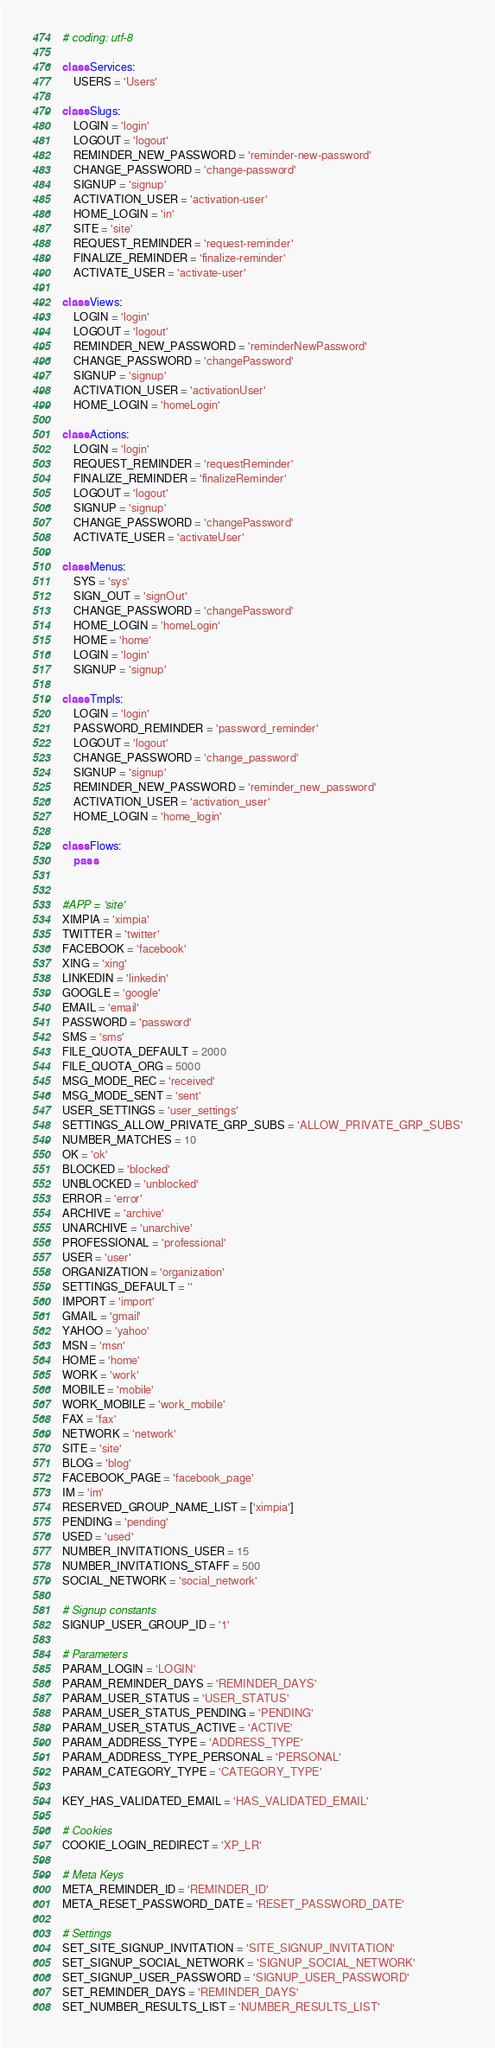Convert code to text. <code><loc_0><loc_0><loc_500><loc_500><_Python_># coding: utf-8

class Services:
    USERS = 'Users'

class Slugs:
    LOGIN = 'login'
    LOGOUT = 'logout'
    REMINDER_NEW_PASSWORD = 'reminder-new-password'
    CHANGE_PASSWORD = 'change-password'
    SIGNUP = 'signup'
    ACTIVATION_USER = 'activation-user'
    HOME_LOGIN = 'in'
    SITE = 'site'
    REQUEST_REMINDER = 'request-reminder'
    FINALIZE_REMINDER = 'finalize-reminder'
    ACTIVATE_USER = 'activate-user'

class Views:
    LOGIN = 'login'
    LOGOUT = 'logout'
    REMINDER_NEW_PASSWORD = 'reminderNewPassword'
    CHANGE_PASSWORD = 'changePassword'
    SIGNUP = 'signup'
    ACTIVATION_USER = 'activationUser'
    HOME_LOGIN = 'homeLogin'

class Actions:
    LOGIN = 'login'
    REQUEST_REMINDER = 'requestReminder'
    FINALIZE_REMINDER = 'finalizeReminder'
    LOGOUT = 'logout'
    SIGNUP = 'signup'
    CHANGE_PASSWORD = 'changePassword'
    ACTIVATE_USER = 'activateUser'    

class Menus:
    SYS = 'sys'
    SIGN_OUT = 'signOut'
    CHANGE_PASSWORD = 'changePassword'
    HOME_LOGIN = 'homeLogin'
    HOME = 'home'
    LOGIN = 'login'
    SIGNUP = 'signup'

class Tmpls:
    LOGIN = 'login'
    PASSWORD_REMINDER = 'password_reminder'
    LOGOUT = 'logout'
    CHANGE_PASSWORD = 'change_password'
    SIGNUP = 'signup'
    REMINDER_NEW_PASSWORD = 'reminder_new_password'
    ACTIVATION_USER = 'activation_user'
    HOME_LOGIN = 'home_login'

class Flows:
    pass


#APP = 'site'
XIMPIA = 'ximpia'
TWITTER = 'twitter'
FACEBOOK = 'facebook'
XING = 'xing'
LINKEDIN = 'linkedin'
GOOGLE = 'google'
EMAIL = 'email'
PASSWORD = 'password'
SMS = 'sms'
FILE_QUOTA_DEFAULT = 2000
FILE_QUOTA_ORG = 5000
MSG_MODE_REC = 'received'
MSG_MODE_SENT = 'sent'
USER_SETTINGS = 'user_settings'
SETTINGS_ALLOW_PRIVATE_GRP_SUBS = 'ALLOW_PRIVATE_GRP_SUBS'
NUMBER_MATCHES = 10
OK = 'ok'
BLOCKED = 'blocked'
UNBLOCKED = 'unblocked'
ERROR = 'error'
ARCHIVE = 'archive'
UNARCHIVE = 'unarchive'
PROFESSIONAL = 'professional'
USER = 'user'
ORGANIZATION = 'organization'
SETTINGS_DEFAULT = ''
IMPORT = 'import'
GMAIL = 'gmail'
YAHOO = 'yahoo'
MSN = 'msn'
HOME = 'home'
WORK = 'work'
MOBILE = 'mobile'
WORK_MOBILE = 'work_mobile'
FAX = 'fax'
NETWORK = 'network'
SITE = 'site'
BLOG = 'blog'
FACEBOOK_PAGE = 'facebook_page'
IM = 'im'
RESERVED_GROUP_NAME_LIST = ['ximpia']
PENDING = 'pending'
USED = 'used'
NUMBER_INVITATIONS_USER = 15
NUMBER_INVITATIONS_STAFF = 500
SOCIAL_NETWORK = 'social_network'

# Signup constants
SIGNUP_USER_GROUP_ID = '1'

# Parameters
PARAM_LOGIN = 'LOGIN'
PARAM_REMINDER_DAYS = 'REMINDER_DAYS'
PARAM_USER_STATUS = 'USER_STATUS'
PARAM_USER_STATUS_PENDING = 'PENDING'
PARAM_USER_STATUS_ACTIVE = 'ACTIVE'
PARAM_ADDRESS_TYPE = 'ADDRESS_TYPE'
PARAM_ADDRESS_TYPE_PERSONAL = 'PERSONAL'
PARAM_CATEGORY_TYPE = 'CATEGORY_TYPE'

KEY_HAS_VALIDATED_EMAIL = 'HAS_VALIDATED_EMAIL'

# Cookies
COOKIE_LOGIN_REDIRECT = 'XP_LR'

# Meta Keys
META_REMINDER_ID = 'REMINDER_ID'
META_RESET_PASSWORD_DATE = 'RESET_PASSWORD_DATE'

# Settings
SET_SITE_SIGNUP_INVITATION = 'SITE_SIGNUP_INVITATION'
SET_SIGNUP_SOCIAL_NETWORK = 'SIGNUP_SOCIAL_NETWORK'
SET_SIGNUP_USER_PASSWORD = 'SIGNUP_USER_PASSWORD'
SET_REMINDER_DAYS = 'REMINDER_DAYS'
SET_NUMBER_RESULTS_LIST = 'NUMBER_RESULTS_LIST'
</code> 